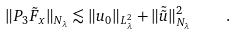<formula> <loc_0><loc_0><loc_500><loc_500>\| P _ { 3 } { \tilde { F } } _ { x } \| _ { N _ { \lambda } } \lesssim \| u _ { 0 } \| _ { L ^ { 2 } _ { \lambda } } + \| { \tilde { \tilde { u } } } \| ^ { 2 } _ { N _ { \lambda } } \quad .</formula> 